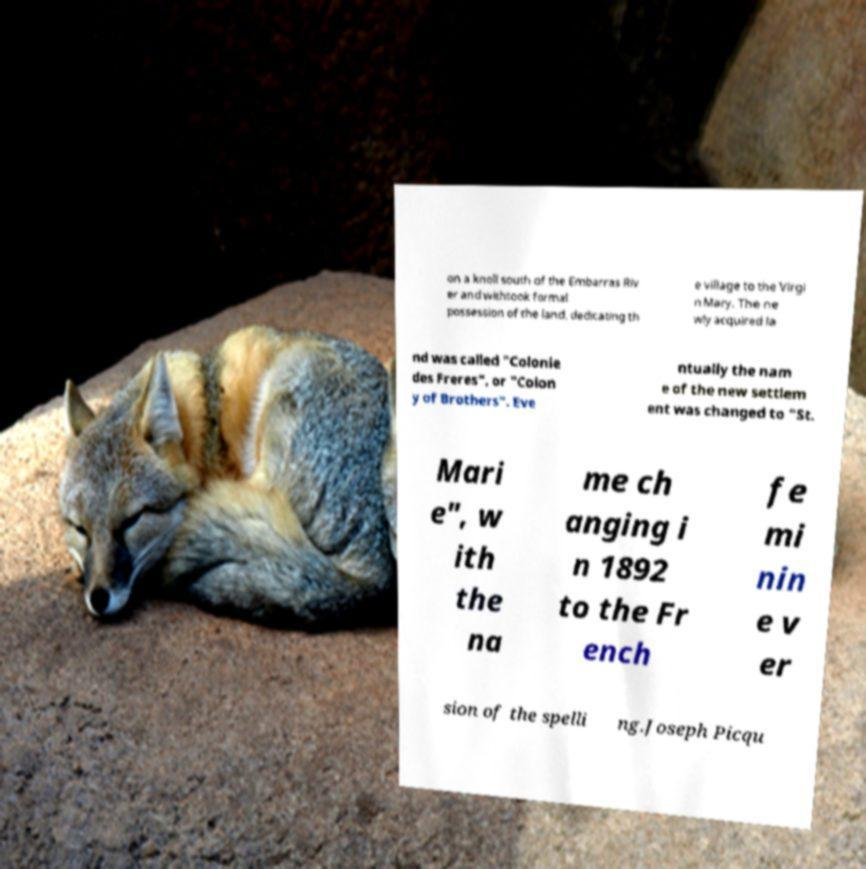For documentation purposes, I need the text within this image transcribed. Could you provide that? on a knoll south of the Embarras Riv er and withtook formal possession of the land, dedicating th e village to the Virgi n Mary. The ne wly acquired la nd was called "Colonie des Freres", or "Colon y of Brothers". Eve ntually the nam e of the new settlem ent was changed to "St. Mari e", w ith the na me ch anging i n 1892 to the Fr ench fe mi nin e v er sion of the spelli ng.Joseph Picqu 